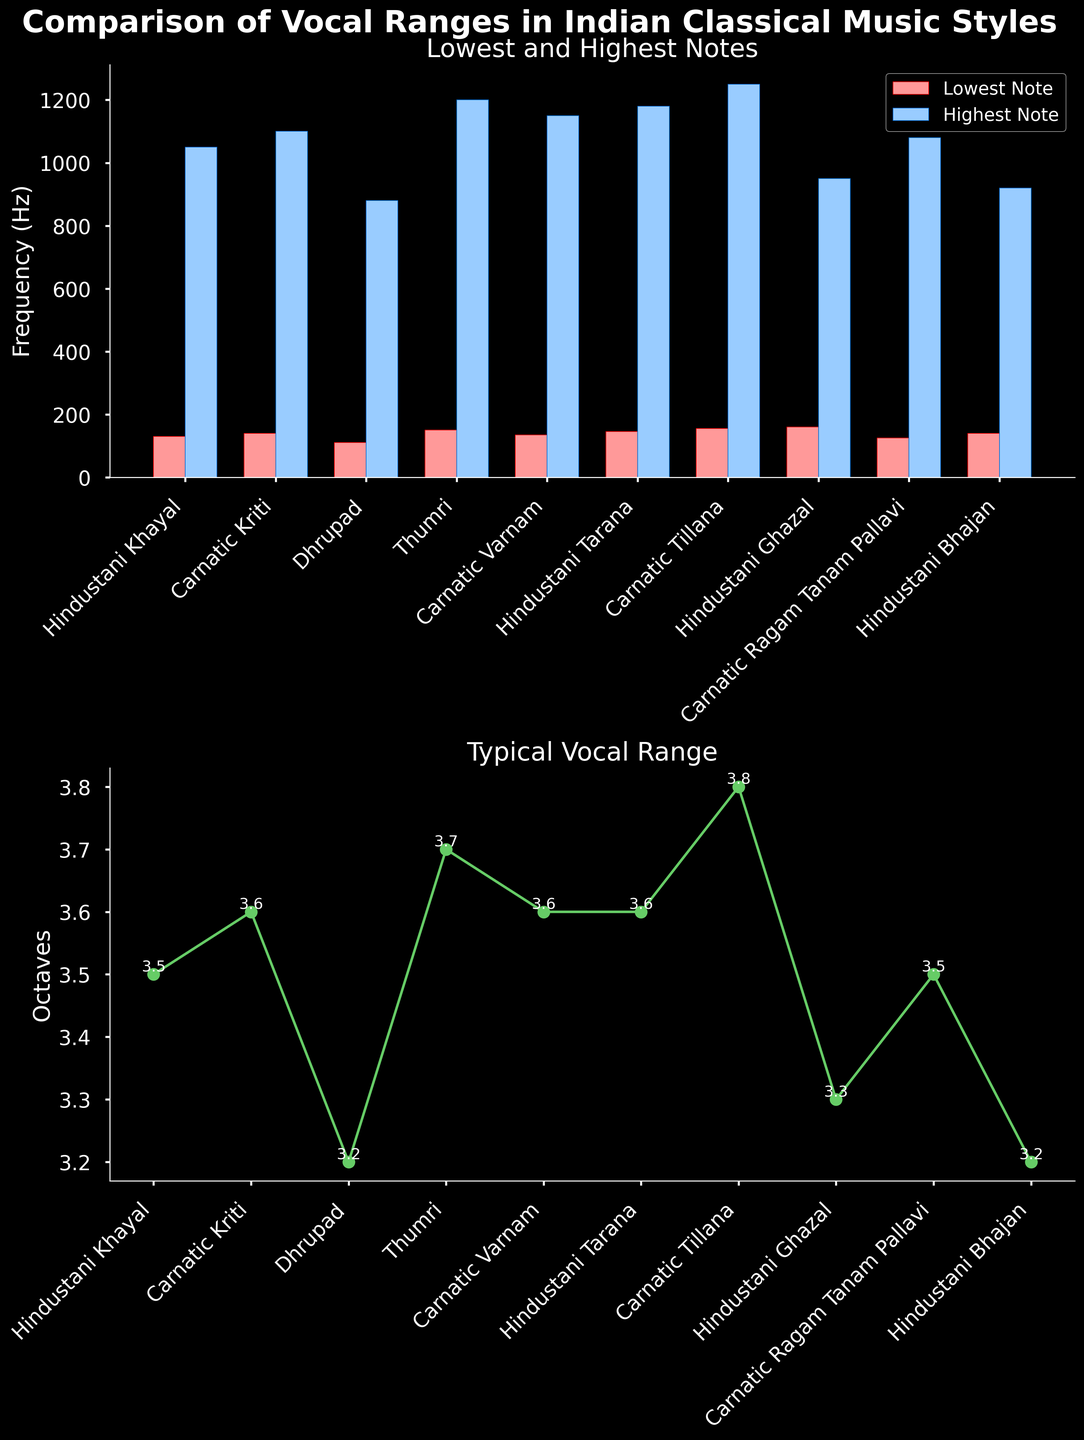Which style has the lowest note on the first bar chart? Looking at the first bar chart, find the bar with the lowest frequency on the left side (Lowest Note) and identify its corresponding style.
Answer: Dhrupad Which two styles share the same typical vocal range in octaves? Refer to the second line plot and look for the data points that are marked with the same numerical value representing the typical vocal range (Octaves).
Answer: Hindustani Khayal and Carnatic Ragam Tanam Pallavi What is the typical vocal range of Carnatic Tillana? Locate the data point in the second plot that corresponds to Carnatic Tillana and read its typical vocal range marked above the point.
Answer: 3.8 octaves Which style has the highest overall typical vocal range and what is it? Look for the data point with the highest value on the second plot and identify the corresponding style and its range.
Answer: Carnatic Tillana, 3.8 octaves Which music style has the highest note and what is its value? Look for the highest data point in the first bar chart (right side), and identify the corresponding style and its note.
Answer: Carnatic Tillana, 1250 Hz 